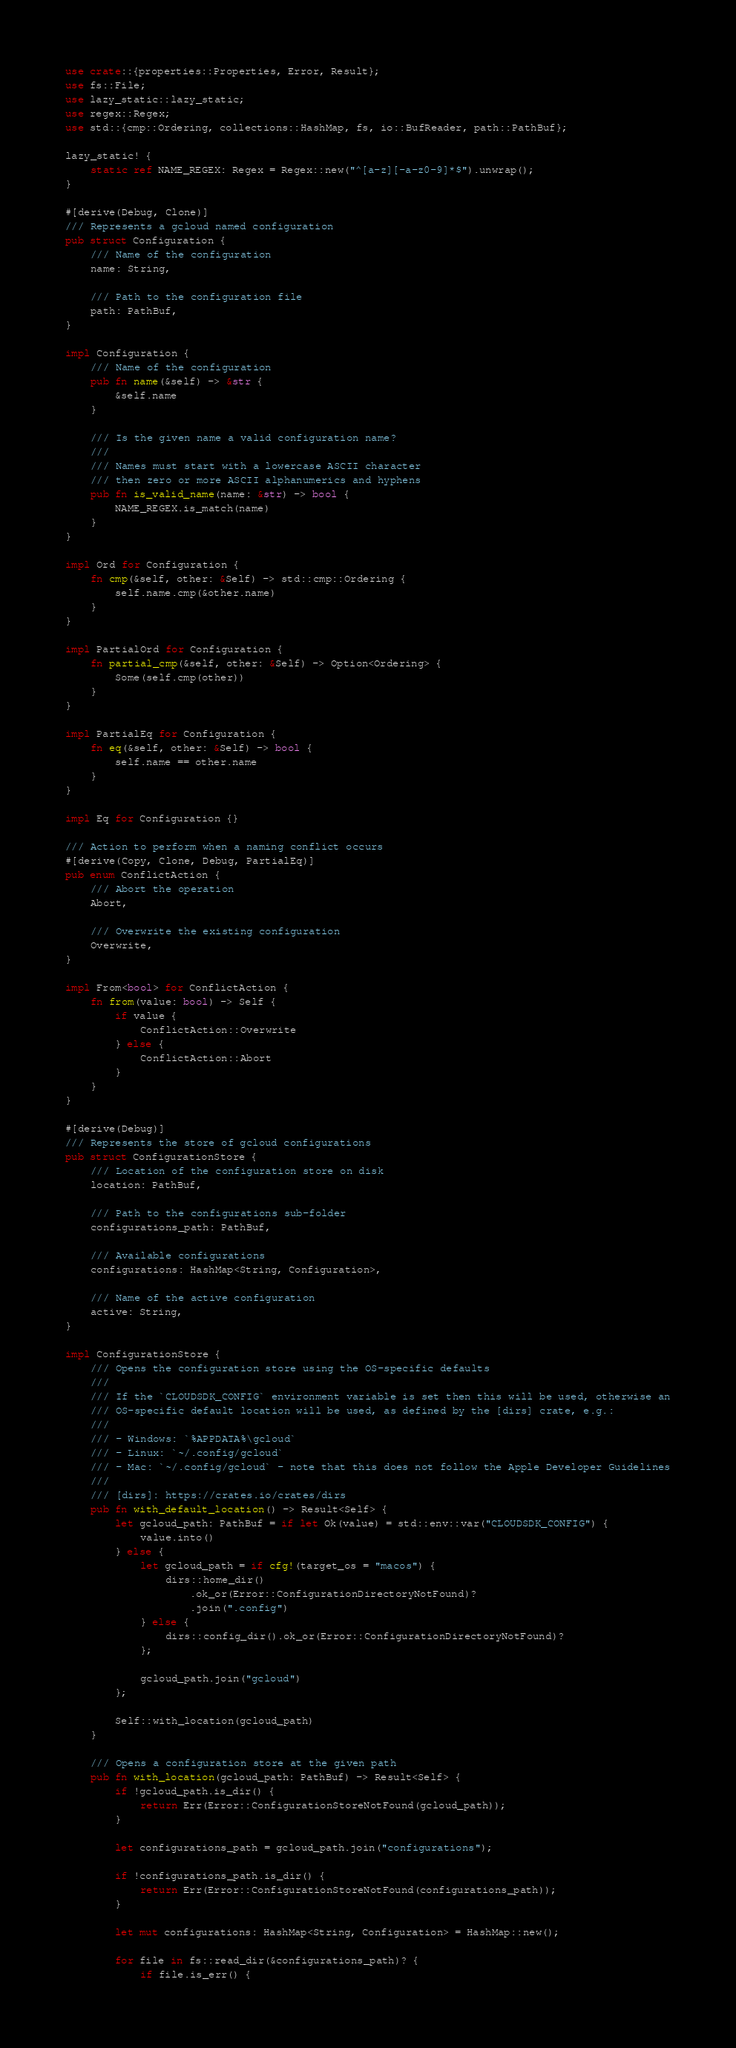<code> <loc_0><loc_0><loc_500><loc_500><_Rust_>use crate::{properties::Properties, Error, Result};
use fs::File;
use lazy_static::lazy_static;
use regex::Regex;
use std::{cmp::Ordering, collections::HashMap, fs, io::BufReader, path::PathBuf};

lazy_static! {
    static ref NAME_REGEX: Regex = Regex::new("^[a-z][-a-z0-9]*$").unwrap();
}

#[derive(Debug, Clone)]
/// Represents a gcloud named configuration
pub struct Configuration {
    /// Name of the configuration
    name: String,

    /// Path to the configuration file
    path: PathBuf,
}

impl Configuration {
    /// Name of the configuration
    pub fn name(&self) -> &str {
        &self.name
    }

    /// Is the given name a valid configuration name?
    ///
    /// Names must start with a lowercase ASCII character
    /// then zero or more ASCII alphanumerics and hyphens
    pub fn is_valid_name(name: &str) -> bool {
        NAME_REGEX.is_match(name)
    }
}

impl Ord for Configuration {
    fn cmp(&self, other: &Self) -> std::cmp::Ordering {
        self.name.cmp(&other.name)
    }
}

impl PartialOrd for Configuration {
    fn partial_cmp(&self, other: &Self) -> Option<Ordering> {
        Some(self.cmp(other))
    }
}

impl PartialEq for Configuration {
    fn eq(&self, other: &Self) -> bool {
        self.name == other.name
    }
}

impl Eq for Configuration {}

/// Action to perform when a naming conflict occurs
#[derive(Copy, Clone, Debug, PartialEq)]
pub enum ConflictAction {
    /// Abort the operation
    Abort,

    /// Overwrite the existing configuration
    Overwrite,
}

impl From<bool> for ConflictAction {
    fn from(value: bool) -> Self {
        if value {
            ConflictAction::Overwrite
        } else {
            ConflictAction::Abort
        }
    }
}

#[derive(Debug)]
/// Represents the store of gcloud configurations
pub struct ConfigurationStore {
    /// Location of the configuration store on disk
    location: PathBuf,

    /// Path to the configurations sub-folder
    configurations_path: PathBuf,

    /// Available configurations
    configurations: HashMap<String, Configuration>,

    /// Name of the active configuration
    active: String,
}

impl ConfigurationStore {
    /// Opens the configuration store using the OS-specific defaults
    ///
    /// If the `CLOUDSDK_CONFIG` environment variable is set then this will be used, otherwise an
    /// OS-specific default location will be used, as defined by the [dirs] crate, e.g.:
    ///
    /// - Windows: `%APPDATA%\gcloud`
    /// - Linux: `~/.config/gcloud`
    /// - Mac: `~/.config/gcloud` - note that this does not follow the Apple Developer Guidelines
    ///
    /// [dirs]: https://crates.io/crates/dirs
    pub fn with_default_location() -> Result<Self> {
        let gcloud_path: PathBuf = if let Ok(value) = std::env::var("CLOUDSDK_CONFIG") {
            value.into()
        } else {
            let gcloud_path = if cfg!(target_os = "macos") {
                dirs::home_dir()
                    .ok_or(Error::ConfigurationDirectoryNotFound)?
                    .join(".config")
            } else {
                dirs::config_dir().ok_or(Error::ConfigurationDirectoryNotFound)?
            };

            gcloud_path.join("gcloud")
        };

        Self::with_location(gcloud_path)
    }

    /// Opens a configuration store at the given path
    pub fn with_location(gcloud_path: PathBuf) -> Result<Self> {
        if !gcloud_path.is_dir() {
            return Err(Error::ConfigurationStoreNotFound(gcloud_path));
        }

        let configurations_path = gcloud_path.join("configurations");

        if !configurations_path.is_dir() {
            return Err(Error::ConfigurationStoreNotFound(configurations_path));
        }

        let mut configurations: HashMap<String, Configuration> = HashMap::new();

        for file in fs::read_dir(&configurations_path)? {
            if file.is_err() {</code> 